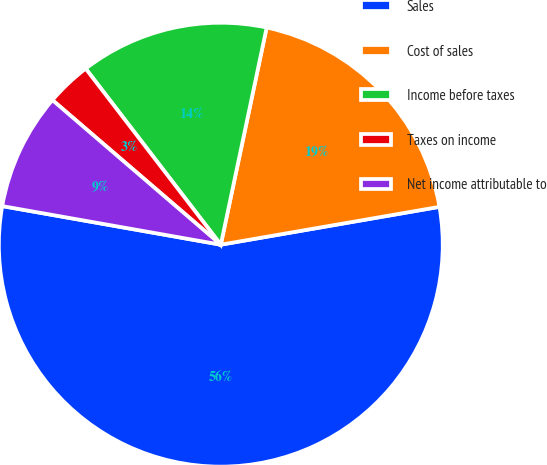Convert chart. <chart><loc_0><loc_0><loc_500><loc_500><pie_chart><fcel>Sales<fcel>Cost of sales<fcel>Income before taxes<fcel>Taxes on income<fcel>Net income attributable to<nl><fcel>55.51%<fcel>18.96%<fcel>13.73%<fcel>3.29%<fcel>8.51%<nl></chart> 